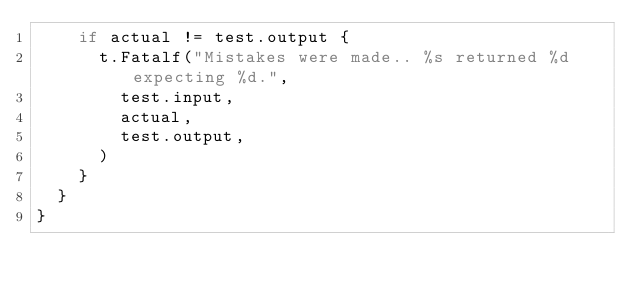<code> <loc_0><loc_0><loc_500><loc_500><_Go_>		if actual != test.output {
			t.Fatalf("Mistakes were made.. %s returned %d expecting %d.", 
				test.input,
				actual, 
				test.output,
			)
		}
	}
}</code> 